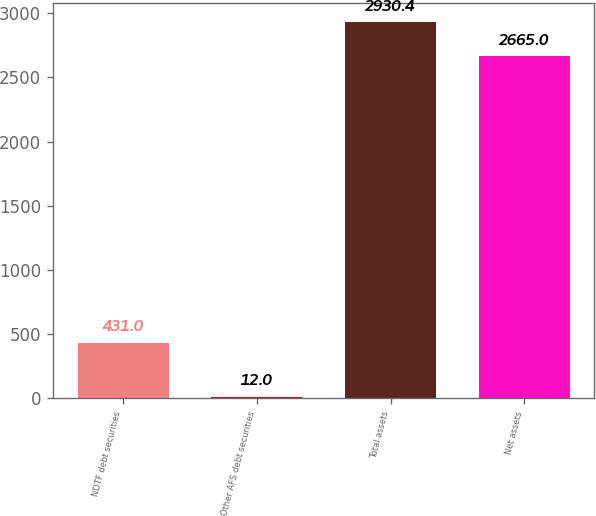Convert chart. <chart><loc_0><loc_0><loc_500><loc_500><bar_chart><fcel>NDTF debt securities<fcel>Other AFS debt securities<fcel>Total assets<fcel>Net assets<nl><fcel>431<fcel>12<fcel>2930.4<fcel>2665<nl></chart> 